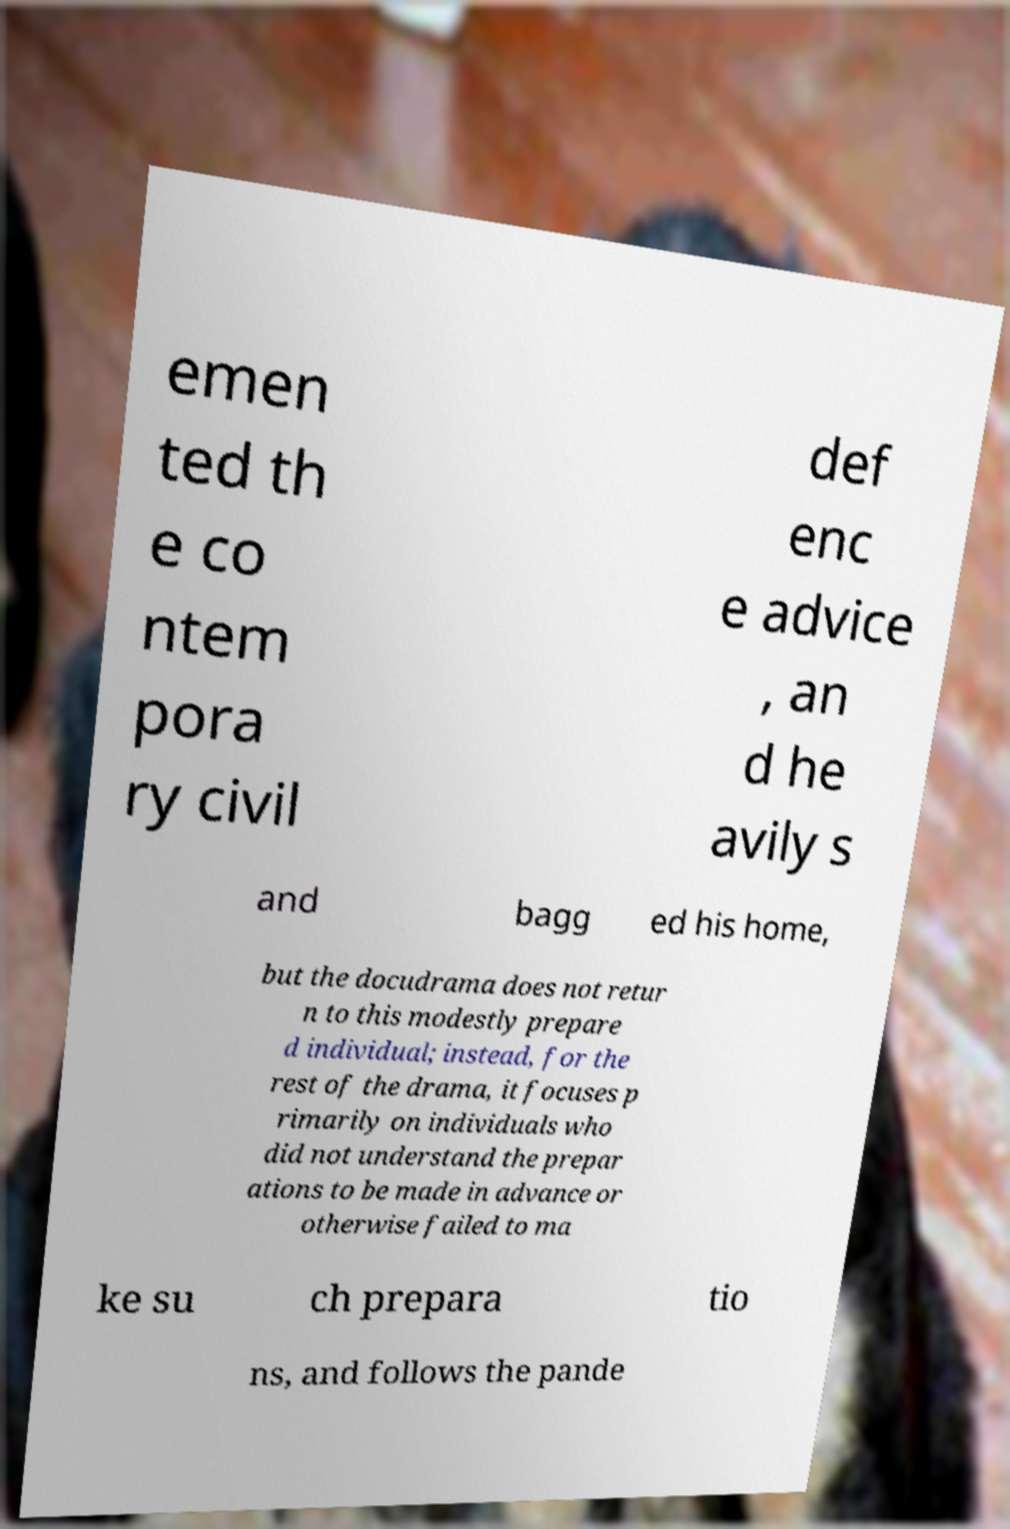Can you accurately transcribe the text from the provided image for me? emen ted th e co ntem pora ry civil def enc e advice , an d he avily s and bagg ed his home, but the docudrama does not retur n to this modestly prepare d individual; instead, for the rest of the drama, it focuses p rimarily on individuals who did not understand the prepar ations to be made in advance or otherwise failed to ma ke su ch prepara tio ns, and follows the pande 